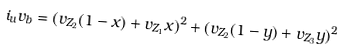Convert formula to latex. <formula><loc_0><loc_0><loc_500><loc_500>i _ { u } v _ { b } = ( v _ { Z _ { 2 } } ( 1 - x ) + v _ { Z _ { 1 } } x ) ^ { 2 } + ( v _ { Z _ { 2 } } ( 1 - y ) + v _ { Z _ { 3 } } y ) ^ { 2 }</formula> 